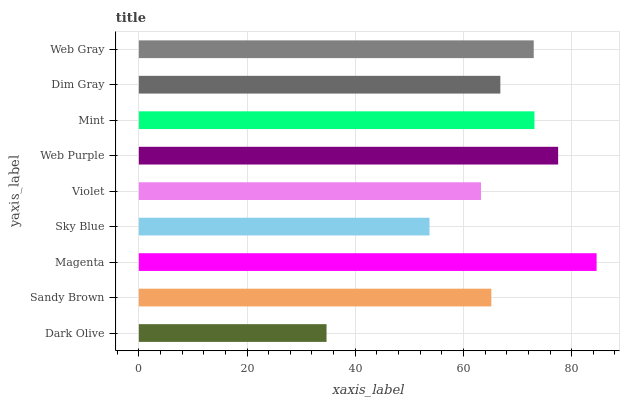Is Dark Olive the minimum?
Answer yes or no. Yes. Is Magenta the maximum?
Answer yes or no. Yes. Is Sandy Brown the minimum?
Answer yes or no. No. Is Sandy Brown the maximum?
Answer yes or no. No. Is Sandy Brown greater than Dark Olive?
Answer yes or no. Yes. Is Dark Olive less than Sandy Brown?
Answer yes or no. Yes. Is Dark Olive greater than Sandy Brown?
Answer yes or no. No. Is Sandy Brown less than Dark Olive?
Answer yes or no. No. Is Dim Gray the high median?
Answer yes or no. Yes. Is Dim Gray the low median?
Answer yes or no. Yes. Is Violet the high median?
Answer yes or no. No. Is Web Gray the low median?
Answer yes or no. No. 